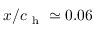<formula> <loc_0><loc_0><loc_500><loc_500>x / c _ { h } \simeq 0 . 0 6</formula> 